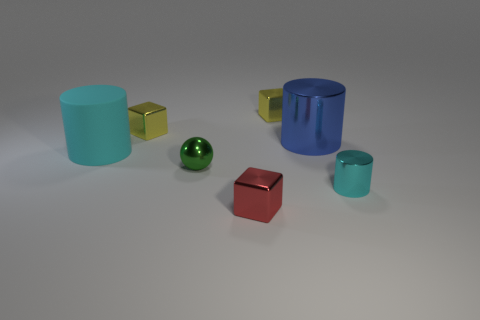Subtract all gray cylinders. How many yellow cubes are left? 2 Add 1 tiny green metal things. How many objects exist? 8 Subtract all small red metal cubes. How many cubes are left? 2 Subtract all gray cylinders. Subtract all gray blocks. How many cylinders are left? 3 Subtract all spheres. How many objects are left? 6 Subtract all large cyan cylinders. Subtract all yellow objects. How many objects are left? 4 Add 5 small green spheres. How many small green spheres are left? 6 Add 1 objects. How many objects exist? 8 Subtract 0 brown cubes. How many objects are left? 7 